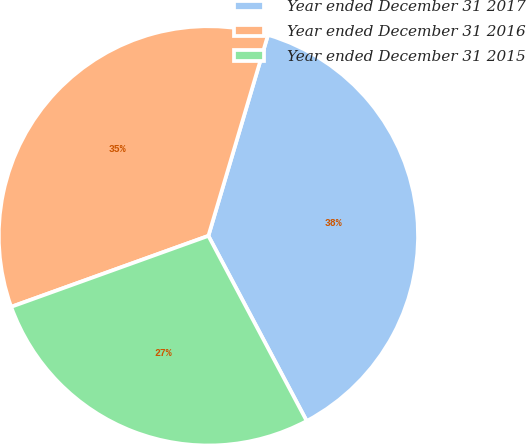Convert chart to OTSL. <chart><loc_0><loc_0><loc_500><loc_500><pie_chart><fcel>Year ended December 31 2017<fcel>Year ended December 31 2016<fcel>Year ended December 31 2015<nl><fcel>37.64%<fcel>35.09%<fcel>27.27%<nl></chart> 